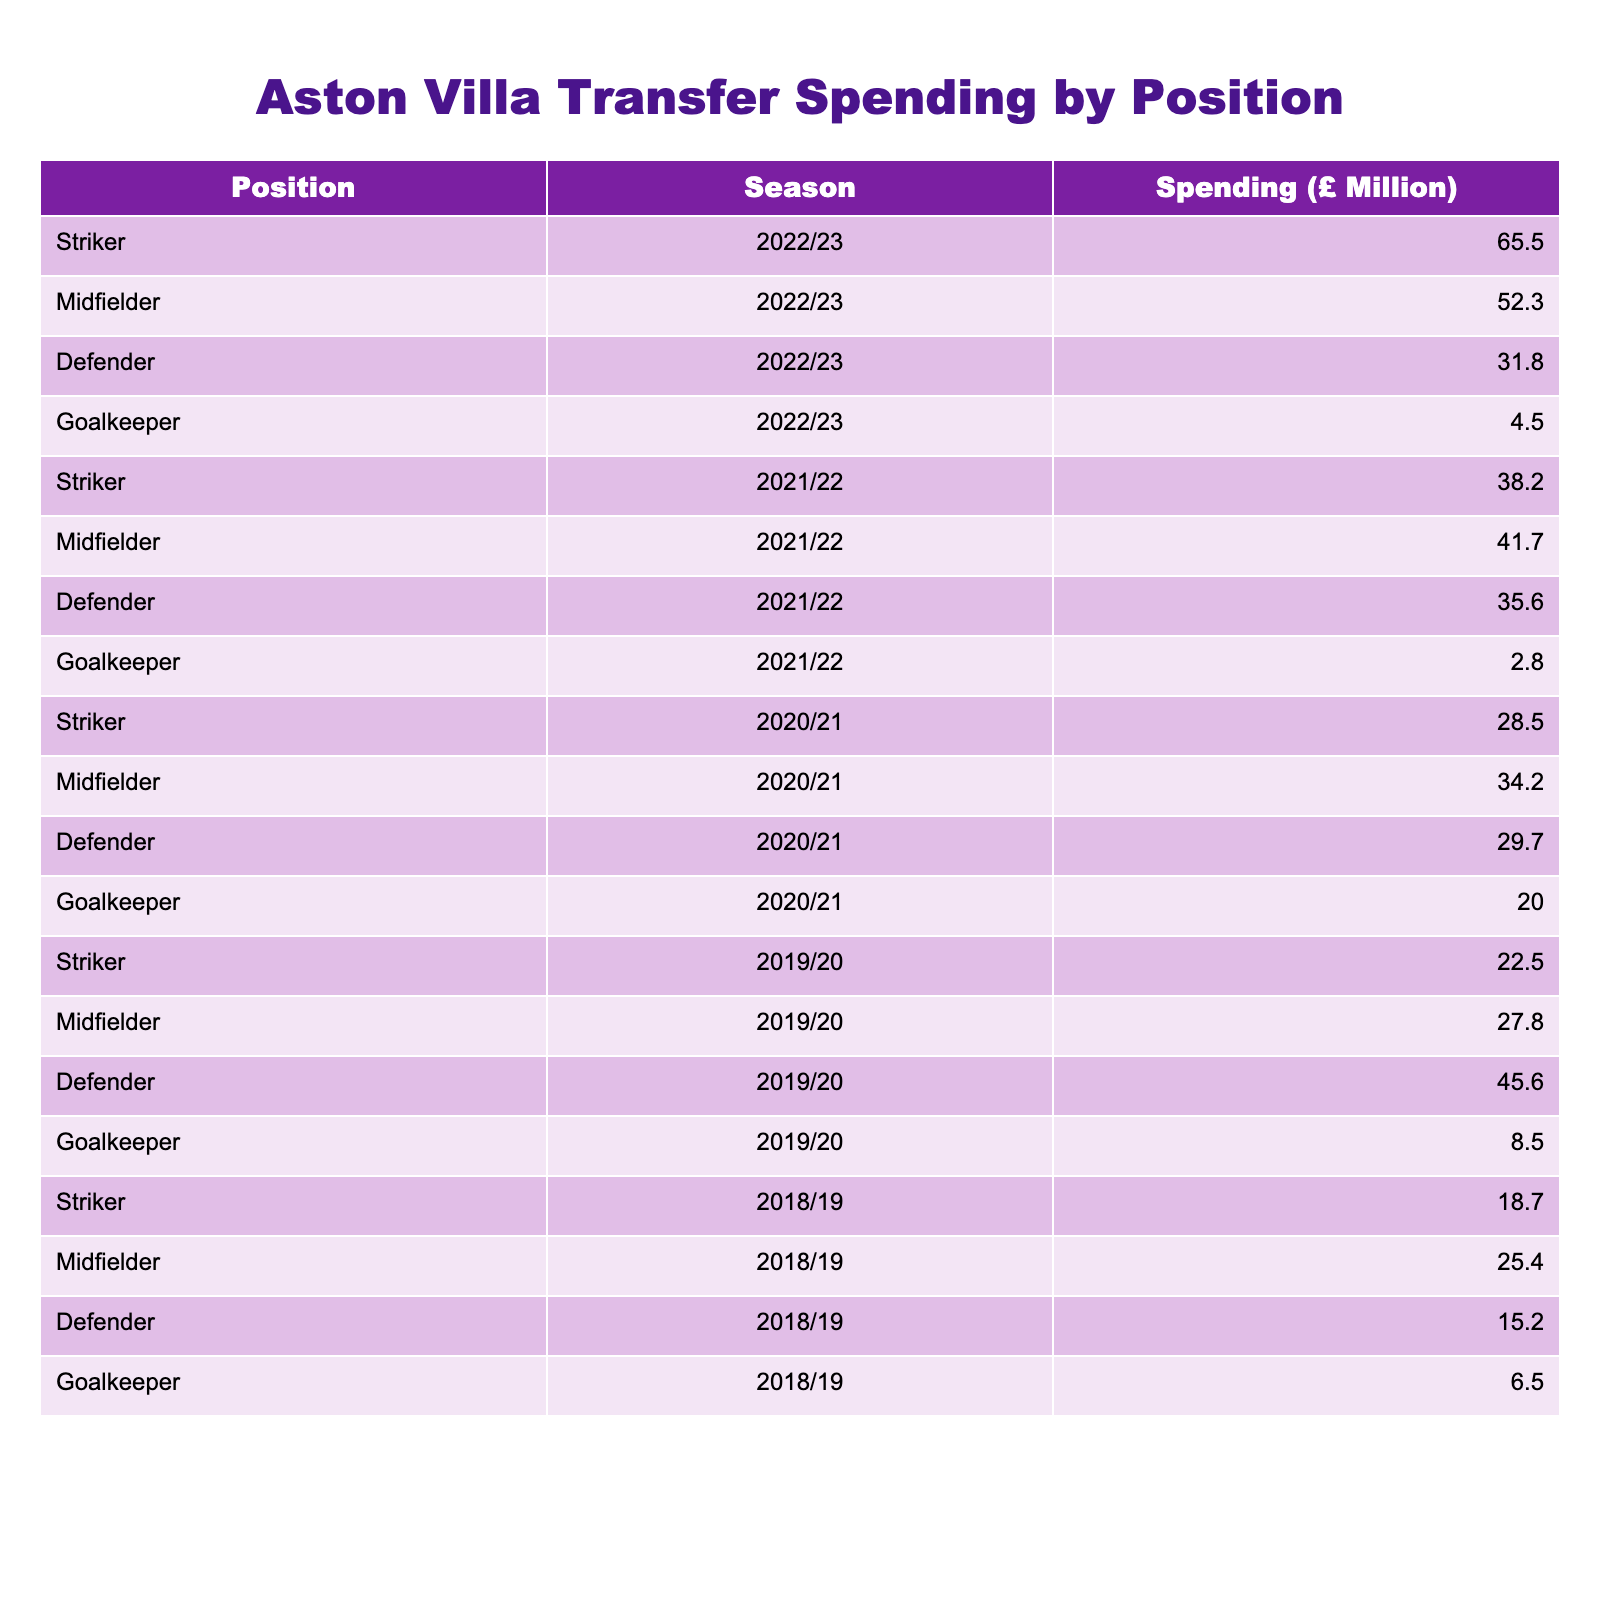What was the total transfer spending on midfielders across all seasons? To find the total, sum the spending on midfielders: 52.3 + 41.7 + 34.2 + 27.8 + 25.4 = 181.4 million.
Answer: 181.4 million In which season did Aston Villa spend the most on defenders? Reviewing the defender spending by season: 31.8 (2022/23), 35.6 (2021/22), 29.7 (2020/21), 45.6 (2019/20), and 15.2 (2018/19). The highest amount is 45.6 million in 2019/20.
Answer: 2019/20 What is the average spending on strikers over the 5 seasons? Calculate the total striker spending: 65.5 + 38.2 + 28.5 + 22.5 + 18.7 = 173.4 million, then divide by 5 seasons: 173.4 / 5 = 34.68 million.
Answer: 34.68 million Did Aston Villa spend more on goalkeepers in the 2020/21 season compared to the previous season? Check the spending for goalkeepers: 20.0 million (2020/21) vs. 2.8 million (2019/20). Since 20.0 > 2.8, the answer is yes.
Answer: Yes Which position had the lowest total spending over the 5 seasons? Calculate the total for each position: Strikers: 173.4, Midfielders: 181.4, Defenders: 152.9, Goalkeepers: 67.8. The lowest is goalkeepers with 67.8 million.
Answer: Goalkeepers What was the spending on defenders in the 2021/22 season compared to the 2022/23 season? Defender spending: 31.8 million (2022/23) vs. 35.6 million (2021/22). Since 31.8 < 35.6, it was less in 2022/23.
Answer: Less During which season did Aston Villa spend over 60 million on any position? Review each position's spending for the seasons: 65.5 million (2022/23, strikers). This is the only instance above 60 million.
Answer: 2022/23 What was the total transfer spending for all positions in the 2019/20 season? Total spending in 2019/20: 22.5 (striker) + 27.8 (midfielder) + 45.6 (defender) + 8.5 (goalkeeper) = 104.4 million.
Answer: 104.4 million Was the increase in striker spending from 2021/22 to 2022/23 greater than the increase in midfielder spending in the same period? Striker spending increased from 38.2 to 65.5 (increase of 27.3 million) and midfielder spending from 41.7 to 52.3 (increase of 10.6 million). The increase in striker spending is greater.
Answer: Yes Which season had the highest overall spending, and how much was it? Total spending by season: 2022/23: 154.1, 2021/22: 118.3, 2020/21: 112.4, 2019/20: 104.4, 2018/19: 75.8. The highest is 2022/23 with 154.1 million.
Answer: 2022/23, 154.1 million 